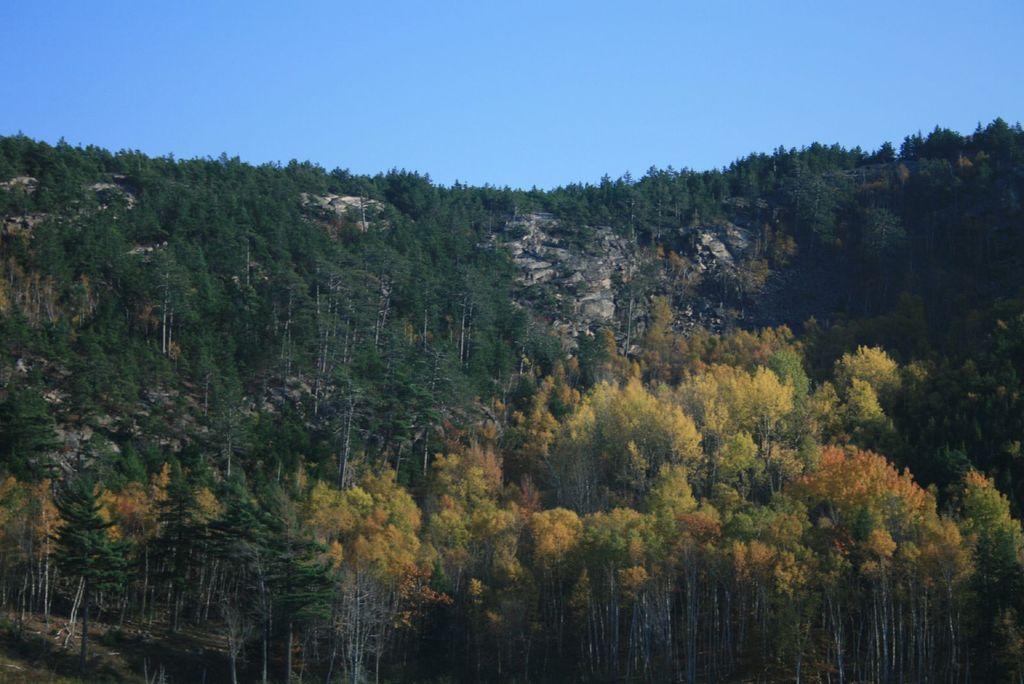In one or two sentences, can you explain what this image depicts? In this image I can see group of trees and the hill ,at the top I can see the sky. 